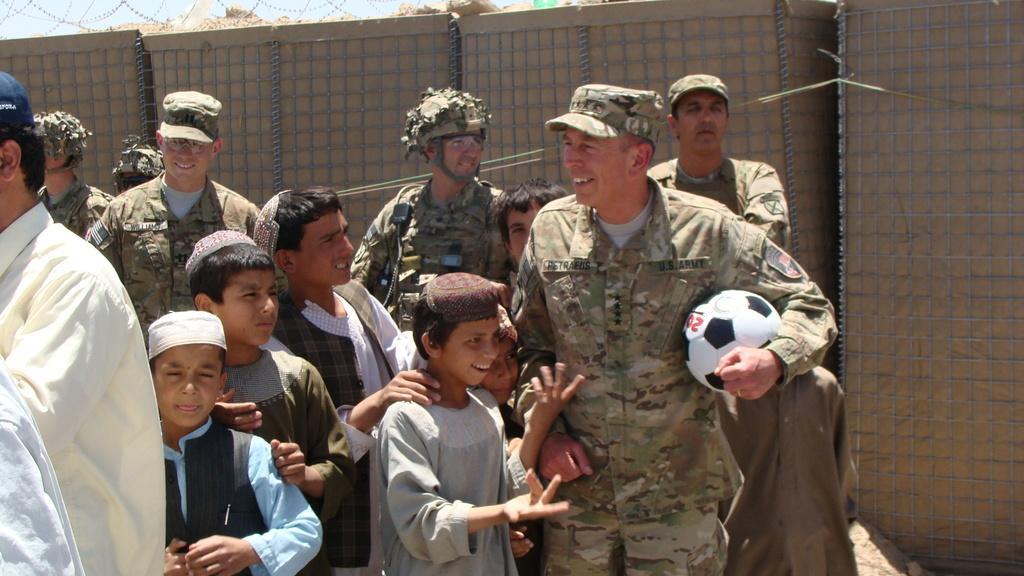Can you describe this image briefly? In the picture there are few soldiers and kids playing football. In the picture all are smiling. In the background there is a fencing. Sky is visible. Soldiers are wearing uniforms. 